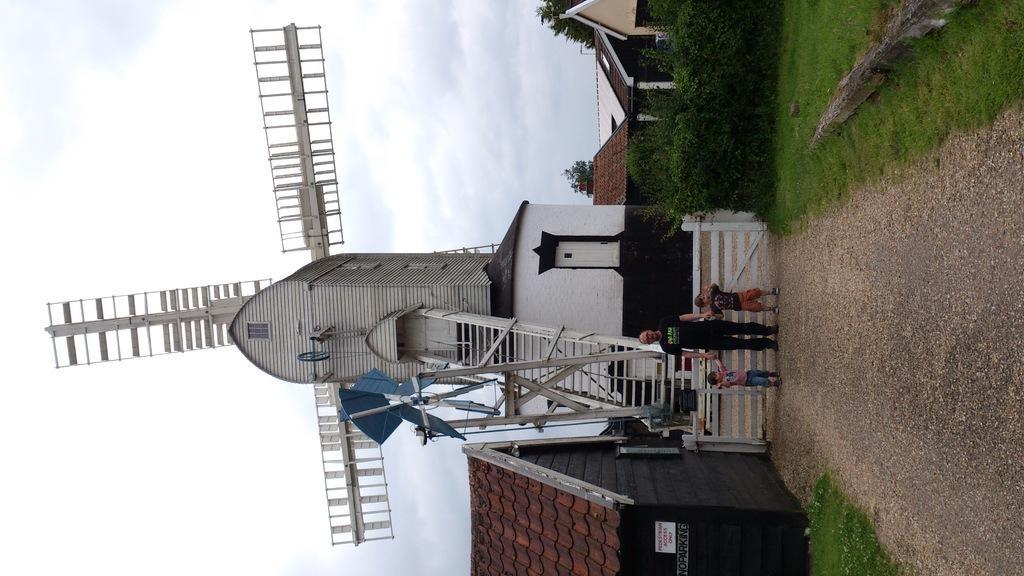How would you summarize this image in a sentence or two? In the picture we can see a windmill with a house and ladder to it and near it, we can see a man standing with two children on the path and besides the path we can see a grass surface and behind it we can see planets, houses and in the background we can see the sky with clouds. 